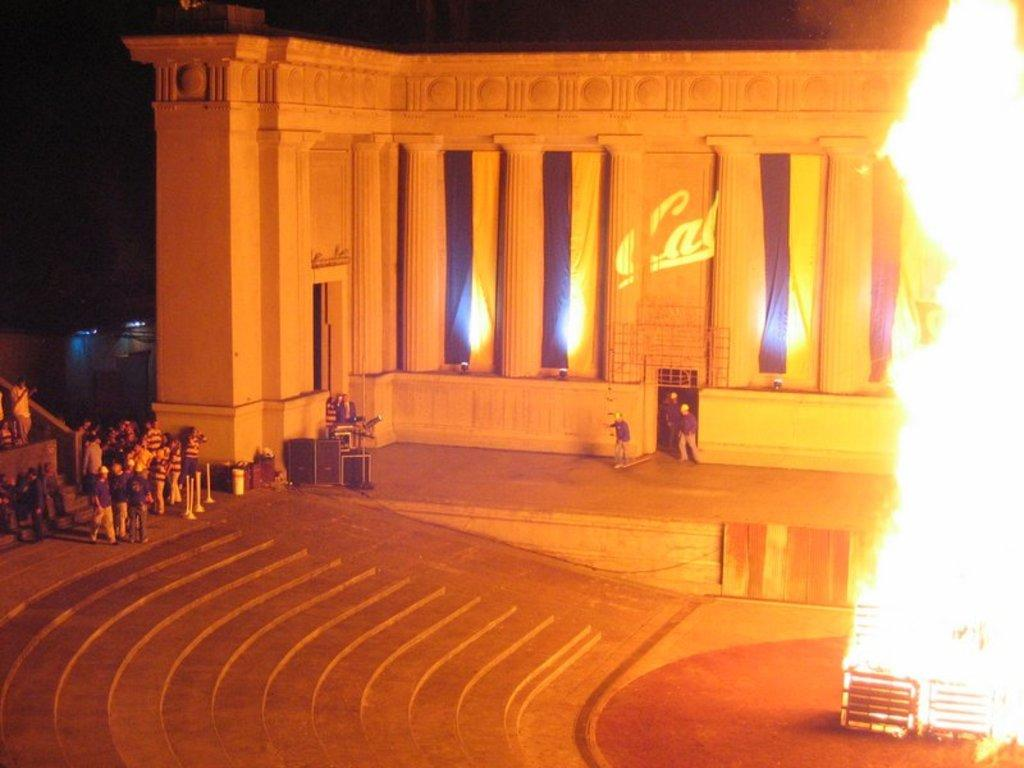What is happening in the image involving people? There are people standing in the image. What objects can be seen related to music? There are musical instruments in the image. What architectural features are present? There are poles and pillars in the image. What is the nature of the fire in the image? There is fire in the image. What color is the background of the image? The background of the image is black. What type of soap is being used by the people in the image? There is no soap present in the image. How long have the people in the image been sleeping? There is no indication of sleep in the image; the people are standing. 